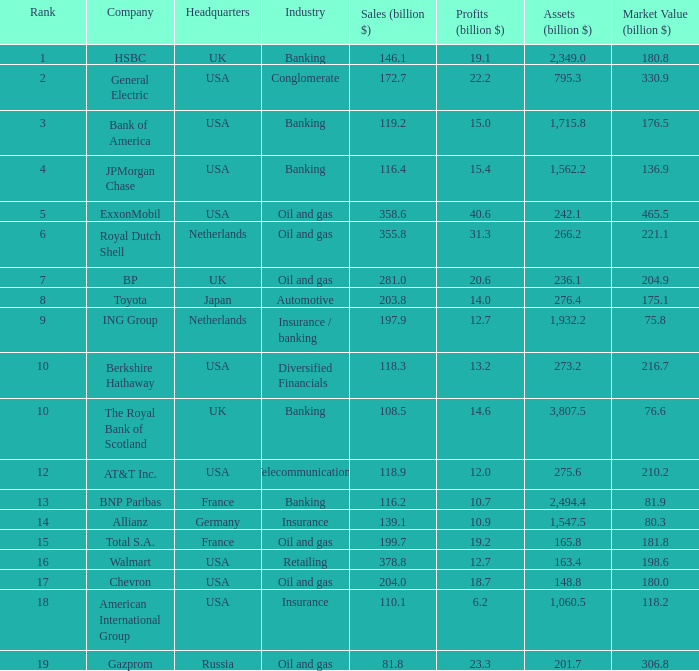What are berkshire hathaway's profits measured in billions? 13.2. 